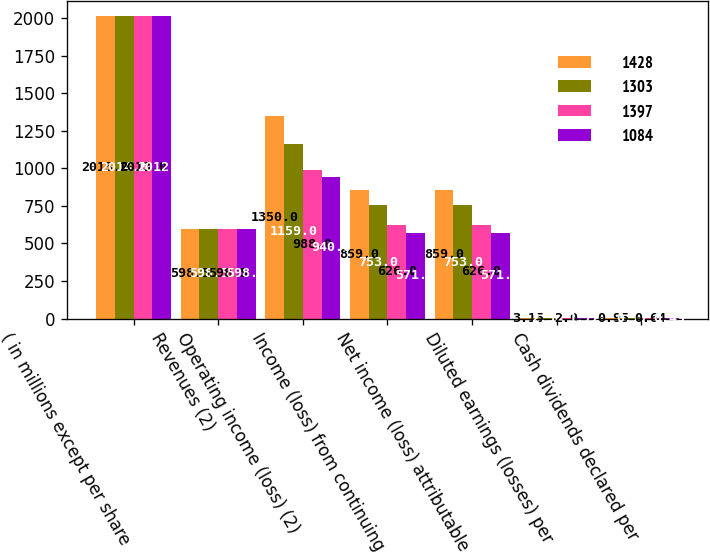<chart> <loc_0><loc_0><loc_500><loc_500><stacked_bar_chart><ecel><fcel>( in millions except per share<fcel>Revenues (2)<fcel>Operating income (loss) (2)<fcel>Income (loss) from continuing<fcel>Net income (loss) attributable<fcel>Diluted earnings (losses) per<fcel>Cash dividends declared per<nl><fcel>1428<fcel>2015<fcel>598.5<fcel>1350<fcel>859<fcel>859<fcel>3.15<fcel>0.95<nl><fcel>1303<fcel>2014<fcel>598.5<fcel>1159<fcel>753<fcel>753<fcel>2.54<fcel>0.77<nl><fcel>1397<fcel>2013<fcel>598.5<fcel>988<fcel>626<fcel>626<fcel>2<fcel>0.64<nl><fcel>1084<fcel>2012<fcel>598.5<fcel>940<fcel>571<fcel>571<fcel>1.72<fcel>0.49<nl></chart> 